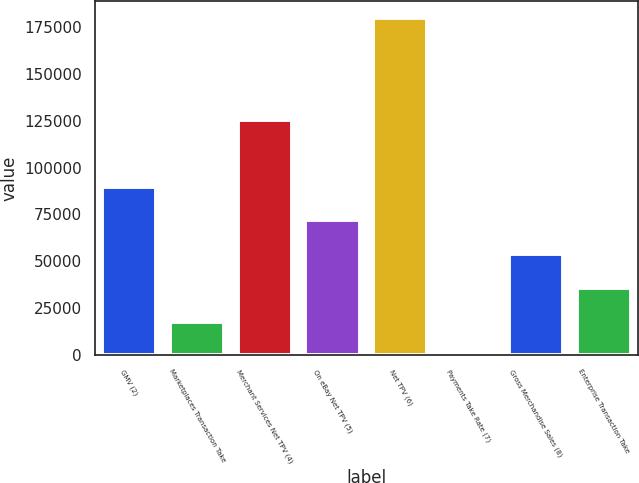Convert chart. <chart><loc_0><loc_0><loc_500><loc_500><bar_chart><fcel>GMV (2)<fcel>Marketplaces Transaction Take<fcel>Merchant Services Net TPV (4)<fcel>On eBay Net TPV (5)<fcel>Net TPV (6)<fcel>Payments Take Rate (7)<fcel>Gross Merchandise Sales (8)<fcel>Enterprise Transaction Take<nl><fcel>89833.3<fcel>17969.6<fcel>125281<fcel>71867.4<fcel>179663<fcel>3.69<fcel>53901.5<fcel>35935.6<nl></chart> 